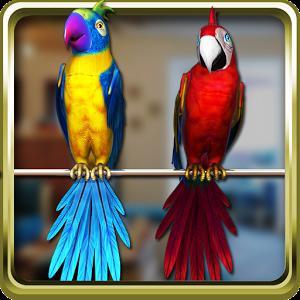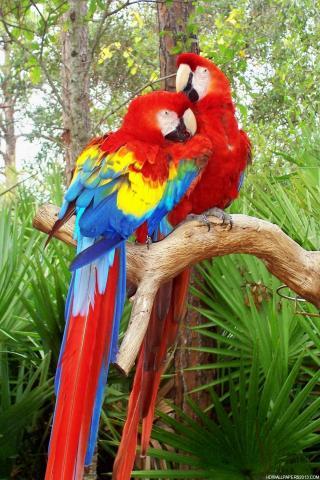The first image is the image on the left, the second image is the image on the right. Given the left and right images, does the statement "One of the images has two matching solid colored birds standing next to each other on the same branch." hold true? Answer yes or no. No. The first image is the image on the left, the second image is the image on the right. Examine the images to the left and right. Is the description "A blue bird is touching another blue bird." accurate? Answer yes or no. No. 